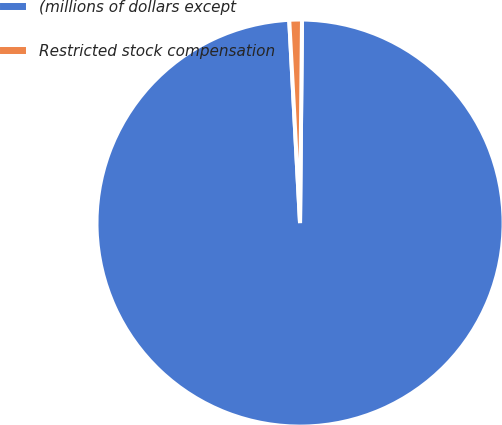Convert chart. <chart><loc_0><loc_0><loc_500><loc_500><pie_chart><fcel>(millions of dollars except<fcel>Restricted stock compensation<nl><fcel>99.0%<fcel>1.0%<nl></chart> 